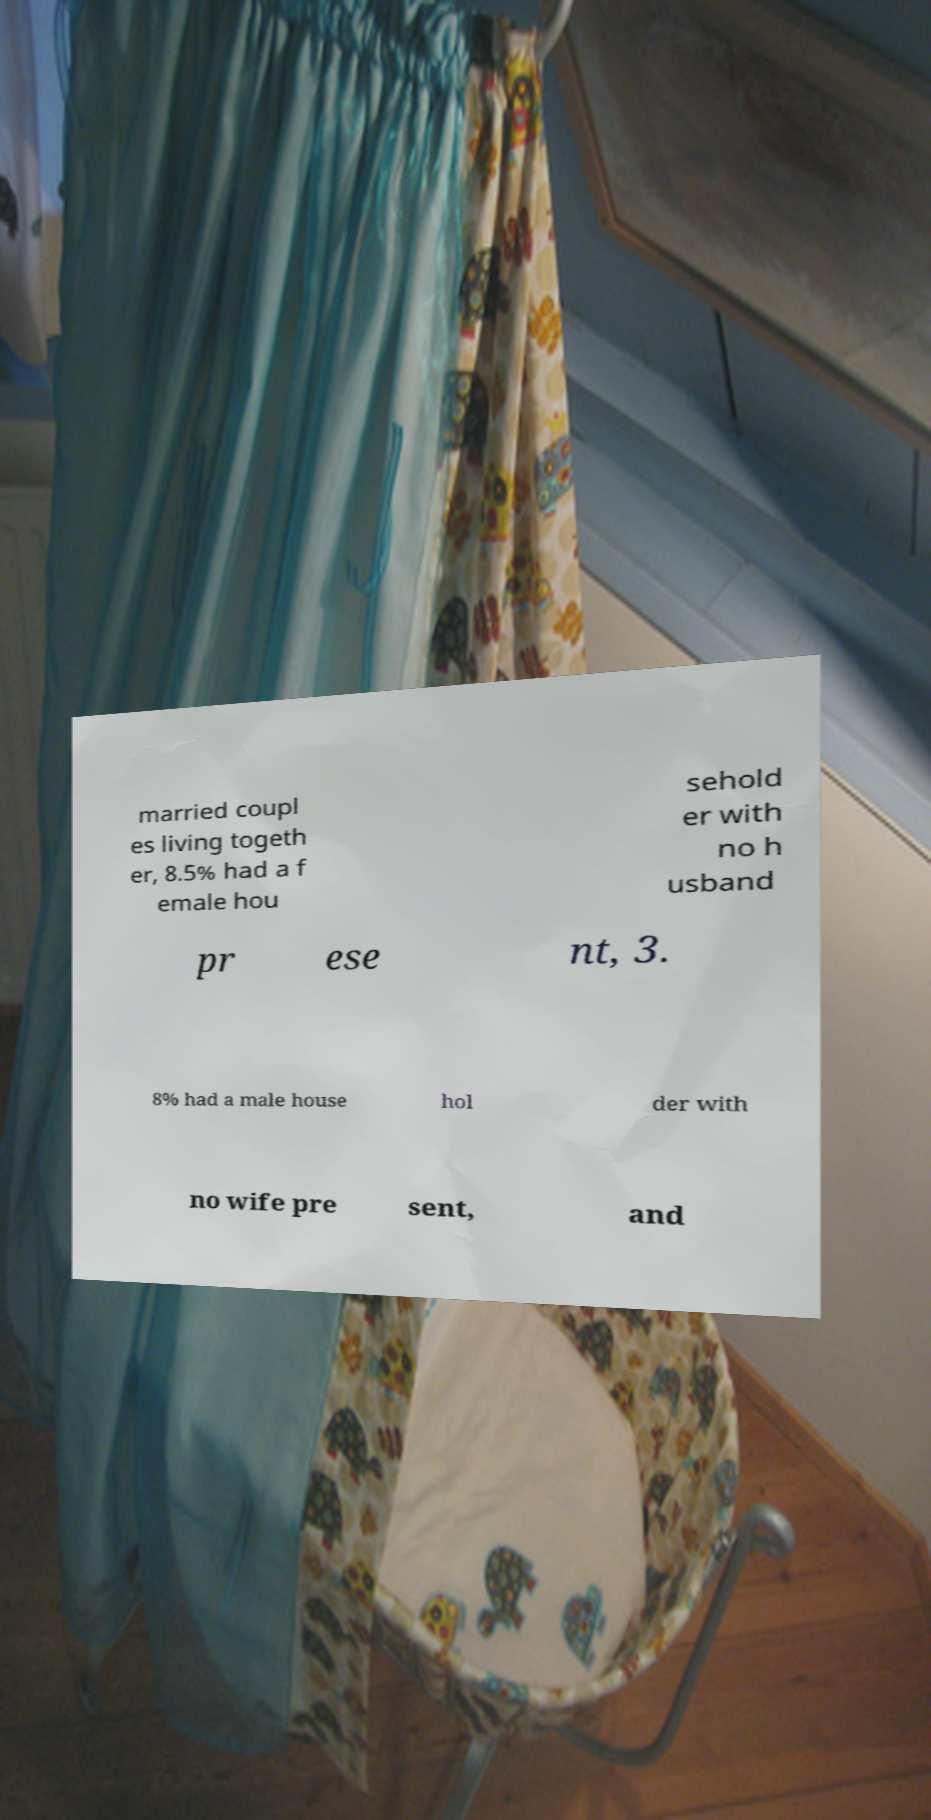Please read and relay the text visible in this image. What does it say? married coupl es living togeth er, 8.5% had a f emale hou sehold er with no h usband pr ese nt, 3. 8% had a male house hol der with no wife pre sent, and 